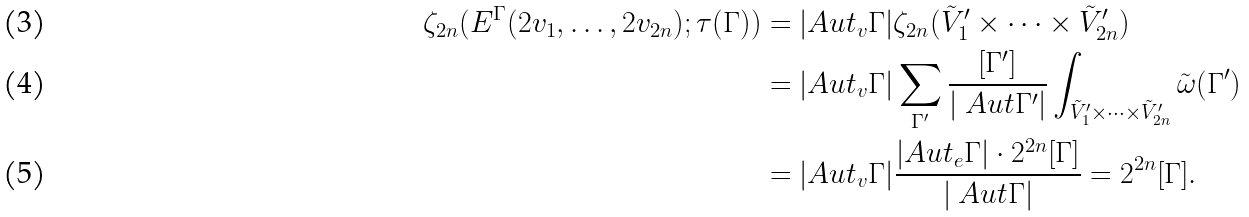<formula> <loc_0><loc_0><loc_500><loc_500>\zeta _ { 2 n } ( E ^ { \Gamma } ( 2 v _ { 1 } , \dots , 2 v _ { 2 n } ) ; \tau ( \Gamma ) ) & = | A u t _ { v } \Gamma | \zeta _ { 2 n } ( \tilde { V } ^ { \prime } _ { 1 } \times \cdots \times \tilde { V } ^ { \prime } _ { 2 n } ) \\ & = | A u t _ { v } \Gamma | \sum _ { \Gamma ^ { \prime } } \frac { [ \Gamma ^ { \prime } ] } { | \ A u t \Gamma ^ { \prime } | } \int _ { \tilde { V } ^ { \prime } _ { 1 } \times \cdots \times \tilde { V } ^ { \prime } _ { 2 n } } \tilde { \omega } ( \Gamma ^ { \prime } ) \\ & = | A u t _ { v } \Gamma | \frac { | A u t _ { e } \Gamma | \cdot 2 ^ { 2 n } [ \Gamma ] } { | \ A u t \Gamma | } = 2 ^ { 2 n } [ \Gamma ] .</formula> 